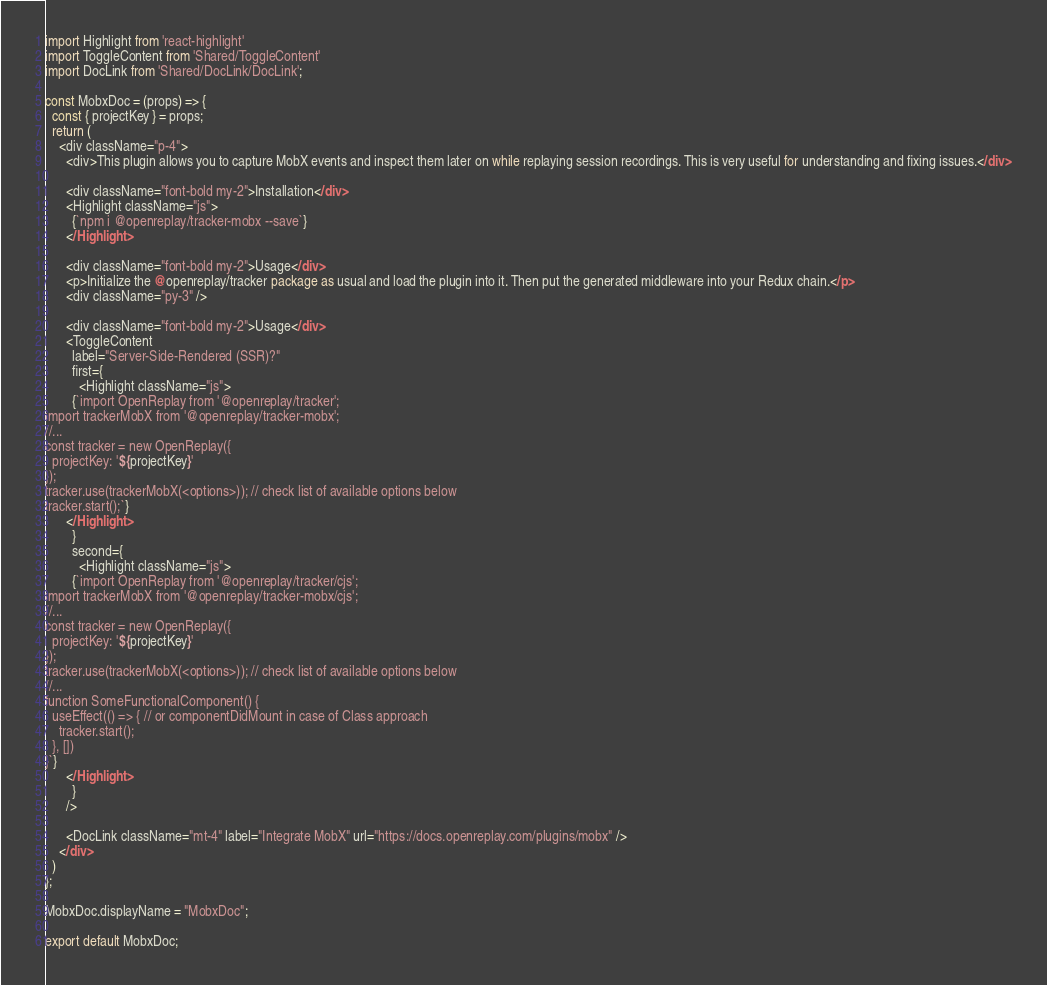Convert code to text. <code><loc_0><loc_0><loc_500><loc_500><_JavaScript_>import Highlight from 'react-highlight'
import ToggleContent from 'Shared/ToggleContent'
import DocLink from 'Shared/DocLink/DocLink';

const MobxDoc = (props) => {
  const { projectKey } = props;
  return (
    <div className="p-4">
      <div>This plugin allows you to capture MobX events and inspect them later on while replaying session recordings. This is very useful for understanding and fixing issues.</div>
      
      <div className="font-bold my-2">Installation</div>
      <Highlight className="js">
        {`npm i @openreplay/tracker-mobx --save`}
      </Highlight>
      
      <div className="font-bold my-2">Usage</div>
      <p>Initialize the @openreplay/tracker package as usual and load the plugin into it. Then put the generated middleware into your Redux chain.</p>
      <div className="py-3" />

      <div className="font-bold my-2">Usage</div>
      <ToggleContent
        label="Server-Side-Rendered (SSR)?"
        first={
          <Highlight className="js">
        {`import OpenReplay from '@openreplay/tracker';
import trackerMobX from '@openreplay/tracker-mobx';
//...
const tracker = new OpenReplay({
  projectKey: '${projectKey}'
});
tracker.use(trackerMobX(<options>)); // check list of available options below
tracker.start();`}
      </Highlight>
        }
        second={
          <Highlight className="js">
        {`import OpenReplay from '@openreplay/tracker/cjs';
import trackerMobX from '@openreplay/tracker-mobx/cjs';
//...
const tracker = new OpenReplay({
  projectKey: '${projectKey}'
});
tracker.use(trackerMobX(<options>)); // check list of available options below
//...
function SomeFunctionalComponent() {
  useEffect(() => { // or componentDidMount in case of Class approach
    tracker.start();
  }, [])
}`}
      </Highlight>
        }
      />

      <DocLink className="mt-4" label="Integrate MobX" url="https://docs.openreplay.com/plugins/mobx" />
    </div>
  )
};

MobxDoc.displayName = "MobxDoc";

export default MobxDoc;
</code> 